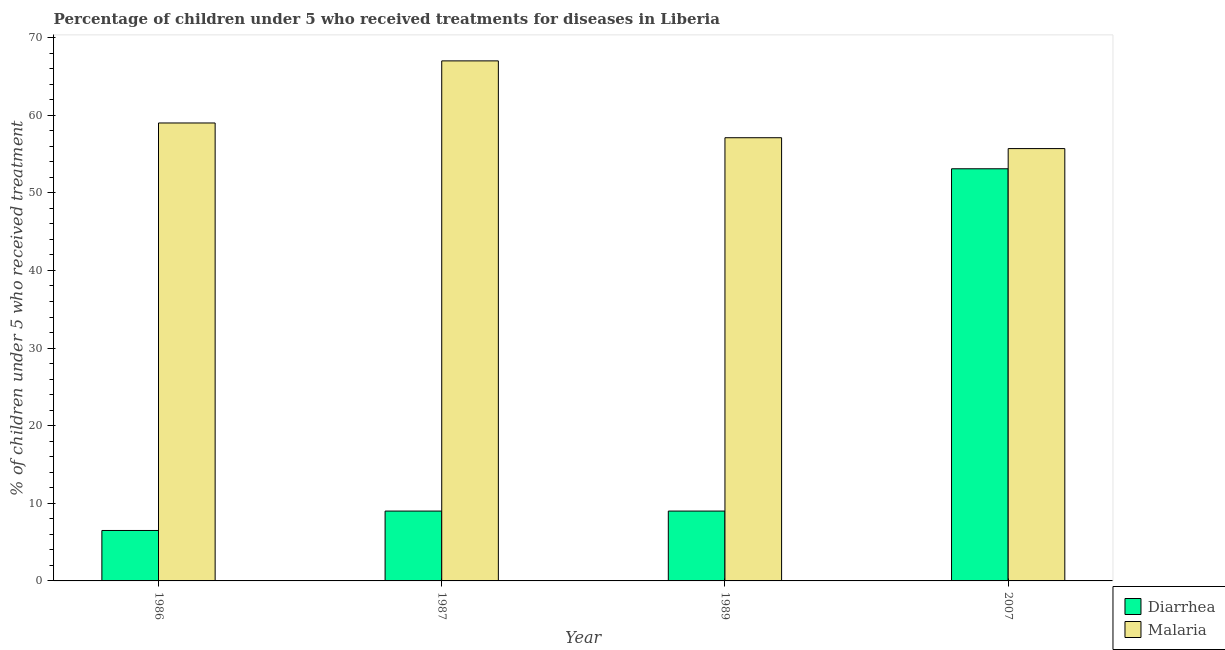How many groups of bars are there?
Your answer should be very brief. 4. How many bars are there on the 1st tick from the left?
Provide a succinct answer. 2. In how many cases, is the number of bars for a given year not equal to the number of legend labels?
Offer a very short reply. 0. What is the percentage of children who received treatment for malaria in 1986?
Keep it short and to the point. 59. Across all years, what is the maximum percentage of children who received treatment for diarrhoea?
Your response must be concise. 53.1. Across all years, what is the minimum percentage of children who received treatment for diarrhoea?
Provide a succinct answer. 6.5. In which year was the percentage of children who received treatment for diarrhoea maximum?
Keep it short and to the point. 2007. What is the total percentage of children who received treatment for malaria in the graph?
Offer a very short reply. 238.8. What is the difference between the percentage of children who received treatment for malaria in 1987 and that in 2007?
Ensure brevity in your answer.  11.3. What is the difference between the percentage of children who received treatment for malaria in 1989 and the percentage of children who received treatment for diarrhoea in 2007?
Provide a short and direct response. 1.4. In the year 1986, what is the difference between the percentage of children who received treatment for malaria and percentage of children who received treatment for diarrhoea?
Your answer should be compact. 0. What is the ratio of the percentage of children who received treatment for malaria in 1986 to that in 1989?
Offer a terse response. 1.03. Is the percentage of children who received treatment for diarrhoea in 1986 less than that in 1987?
Give a very brief answer. Yes. Is the difference between the percentage of children who received treatment for diarrhoea in 1986 and 2007 greater than the difference between the percentage of children who received treatment for malaria in 1986 and 2007?
Your response must be concise. No. What is the difference between the highest and the second highest percentage of children who received treatment for malaria?
Your answer should be very brief. 8. What is the difference between the highest and the lowest percentage of children who received treatment for malaria?
Make the answer very short. 11.3. Is the sum of the percentage of children who received treatment for diarrhoea in 1986 and 2007 greater than the maximum percentage of children who received treatment for malaria across all years?
Give a very brief answer. Yes. What does the 2nd bar from the left in 1986 represents?
Provide a short and direct response. Malaria. What does the 1st bar from the right in 1986 represents?
Your answer should be compact. Malaria. How many years are there in the graph?
Your response must be concise. 4. What is the difference between two consecutive major ticks on the Y-axis?
Provide a short and direct response. 10. Are the values on the major ticks of Y-axis written in scientific E-notation?
Ensure brevity in your answer.  No. Does the graph contain any zero values?
Offer a terse response. No. Where does the legend appear in the graph?
Ensure brevity in your answer.  Bottom right. How are the legend labels stacked?
Keep it short and to the point. Vertical. What is the title of the graph?
Keep it short and to the point. Percentage of children under 5 who received treatments for diseases in Liberia. Does "Diesel" appear as one of the legend labels in the graph?
Ensure brevity in your answer.  No. What is the label or title of the Y-axis?
Give a very brief answer. % of children under 5 who received treatment. What is the % of children under 5 who received treatment in Malaria in 1986?
Make the answer very short. 59. What is the % of children under 5 who received treatment of Diarrhea in 1987?
Offer a terse response. 9. What is the % of children under 5 who received treatment in Malaria in 1987?
Your response must be concise. 67. What is the % of children under 5 who received treatment in Malaria in 1989?
Your answer should be very brief. 57.1. What is the % of children under 5 who received treatment in Diarrhea in 2007?
Offer a very short reply. 53.1. What is the % of children under 5 who received treatment of Malaria in 2007?
Your response must be concise. 55.7. Across all years, what is the maximum % of children under 5 who received treatment of Diarrhea?
Give a very brief answer. 53.1. Across all years, what is the maximum % of children under 5 who received treatment in Malaria?
Your response must be concise. 67. Across all years, what is the minimum % of children under 5 who received treatment in Malaria?
Ensure brevity in your answer.  55.7. What is the total % of children under 5 who received treatment of Diarrhea in the graph?
Make the answer very short. 77.6. What is the total % of children under 5 who received treatment of Malaria in the graph?
Your answer should be compact. 238.8. What is the difference between the % of children under 5 who received treatment of Diarrhea in 1986 and that in 1987?
Provide a succinct answer. -2.5. What is the difference between the % of children under 5 who received treatment in Diarrhea in 1986 and that in 1989?
Ensure brevity in your answer.  -2.5. What is the difference between the % of children under 5 who received treatment of Diarrhea in 1986 and that in 2007?
Keep it short and to the point. -46.6. What is the difference between the % of children under 5 who received treatment of Malaria in 1986 and that in 2007?
Provide a succinct answer. 3.3. What is the difference between the % of children under 5 who received treatment of Diarrhea in 1987 and that in 1989?
Provide a short and direct response. 0. What is the difference between the % of children under 5 who received treatment of Malaria in 1987 and that in 1989?
Make the answer very short. 9.9. What is the difference between the % of children under 5 who received treatment of Diarrhea in 1987 and that in 2007?
Offer a terse response. -44.1. What is the difference between the % of children under 5 who received treatment in Diarrhea in 1989 and that in 2007?
Give a very brief answer. -44.1. What is the difference between the % of children under 5 who received treatment in Diarrhea in 1986 and the % of children under 5 who received treatment in Malaria in 1987?
Provide a short and direct response. -60.5. What is the difference between the % of children under 5 who received treatment of Diarrhea in 1986 and the % of children under 5 who received treatment of Malaria in 1989?
Offer a very short reply. -50.6. What is the difference between the % of children under 5 who received treatment of Diarrhea in 1986 and the % of children under 5 who received treatment of Malaria in 2007?
Offer a very short reply. -49.2. What is the difference between the % of children under 5 who received treatment of Diarrhea in 1987 and the % of children under 5 who received treatment of Malaria in 1989?
Make the answer very short. -48.1. What is the difference between the % of children under 5 who received treatment in Diarrhea in 1987 and the % of children under 5 who received treatment in Malaria in 2007?
Provide a short and direct response. -46.7. What is the difference between the % of children under 5 who received treatment in Diarrhea in 1989 and the % of children under 5 who received treatment in Malaria in 2007?
Give a very brief answer. -46.7. What is the average % of children under 5 who received treatment in Malaria per year?
Give a very brief answer. 59.7. In the year 1986, what is the difference between the % of children under 5 who received treatment of Diarrhea and % of children under 5 who received treatment of Malaria?
Offer a terse response. -52.5. In the year 1987, what is the difference between the % of children under 5 who received treatment in Diarrhea and % of children under 5 who received treatment in Malaria?
Your answer should be compact. -58. In the year 1989, what is the difference between the % of children under 5 who received treatment in Diarrhea and % of children under 5 who received treatment in Malaria?
Your answer should be very brief. -48.1. What is the ratio of the % of children under 5 who received treatment of Diarrhea in 1986 to that in 1987?
Your answer should be compact. 0.72. What is the ratio of the % of children under 5 who received treatment of Malaria in 1986 to that in 1987?
Your answer should be compact. 0.88. What is the ratio of the % of children under 5 who received treatment in Diarrhea in 1986 to that in 1989?
Your answer should be very brief. 0.72. What is the ratio of the % of children under 5 who received treatment of Diarrhea in 1986 to that in 2007?
Ensure brevity in your answer.  0.12. What is the ratio of the % of children under 5 who received treatment in Malaria in 1986 to that in 2007?
Make the answer very short. 1.06. What is the ratio of the % of children under 5 who received treatment of Malaria in 1987 to that in 1989?
Your answer should be compact. 1.17. What is the ratio of the % of children under 5 who received treatment of Diarrhea in 1987 to that in 2007?
Offer a terse response. 0.17. What is the ratio of the % of children under 5 who received treatment in Malaria in 1987 to that in 2007?
Keep it short and to the point. 1.2. What is the ratio of the % of children under 5 who received treatment of Diarrhea in 1989 to that in 2007?
Ensure brevity in your answer.  0.17. What is the ratio of the % of children under 5 who received treatment in Malaria in 1989 to that in 2007?
Provide a short and direct response. 1.03. What is the difference between the highest and the second highest % of children under 5 who received treatment in Diarrhea?
Give a very brief answer. 44.1. What is the difference between the highest and the lowest % of children under 5 who received treatment of Diarrhea?
Your response must be concise. 46.6. What is the difference between the highest and the lowest % of children under 5 who received treatment in Malaria?
Provide a succinct answer. 11.3. 